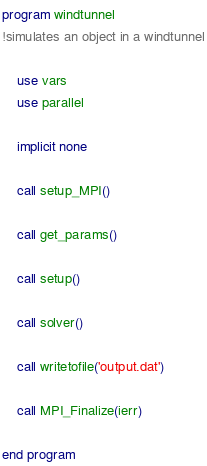<code> <loc_0><loc_0><loc_500><loc_500><_FORTRAN_>program windtunnel
!simulates an object in a windtunnel

    use vars
    use parallel

    implicit none

    call setup_MPI()

    call get_params()

    call setup()

    call solver()

    call writetofile('output.dat')

    call MPI_Finalize(ierr)

end program
</code> 